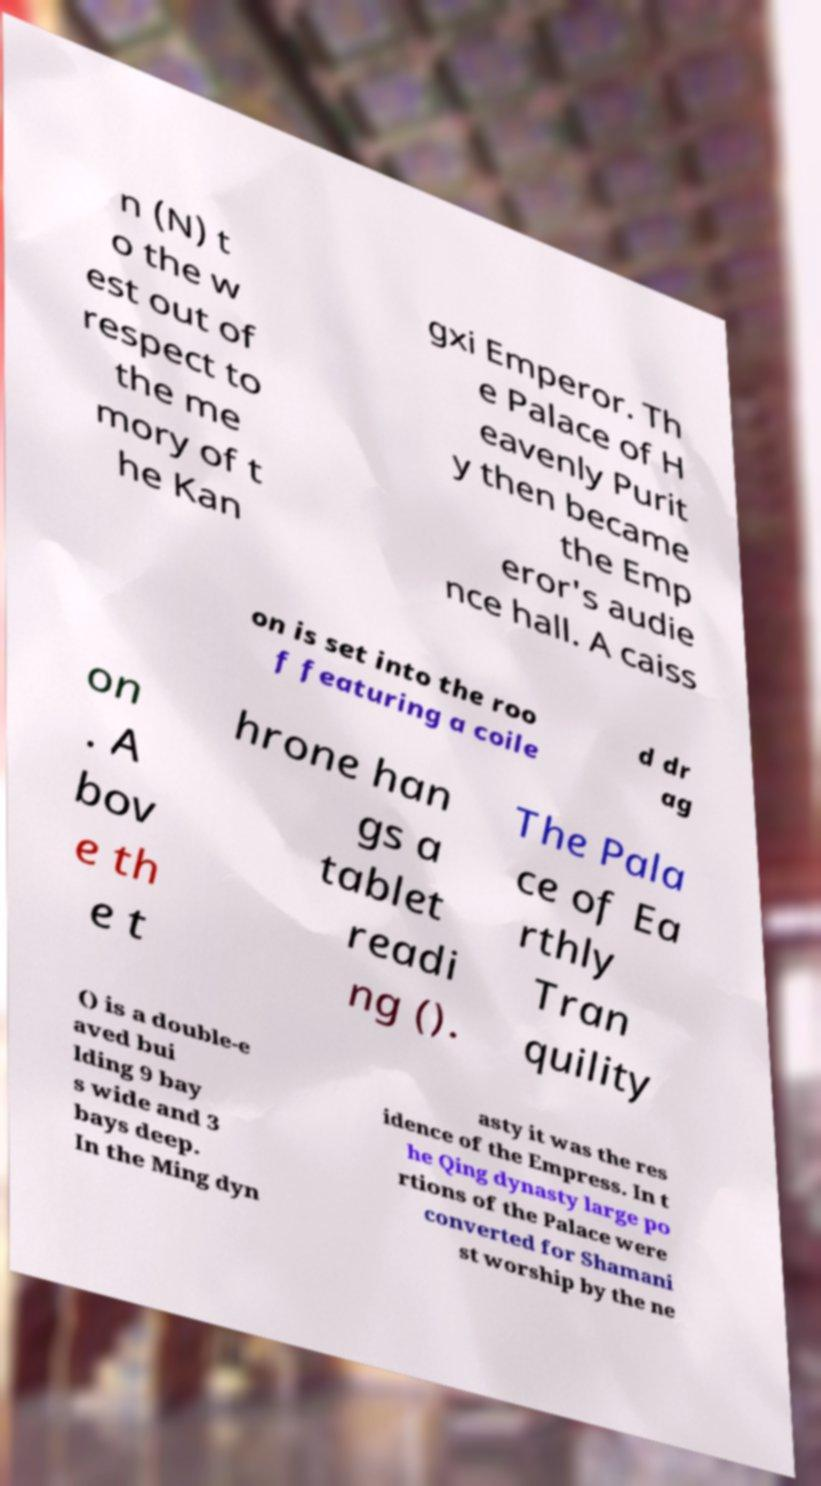For documentation purposes, I need the text within this image transcribed. Could you provide that? n (N) t o the w est out of respect to the me mory of t he Kan gxi Emperor. Th e Palace of H eavenly Purit y then became the Emp eror's audie nce hall. A caiss on is set into the roo f featuring a coile d dr ag on . A bov e th e t hrone han gs a tablet readi ng (). The Pala ce of Ea rthly Tran quility () is a double-e aved bui lding 9 bay s wide and 3 bays deep. In the Ming dyn asty it was the res idence of the Empress. In t he Qing dynasty large po rtions of the Palace were converted for Shamani st worship by the ne 